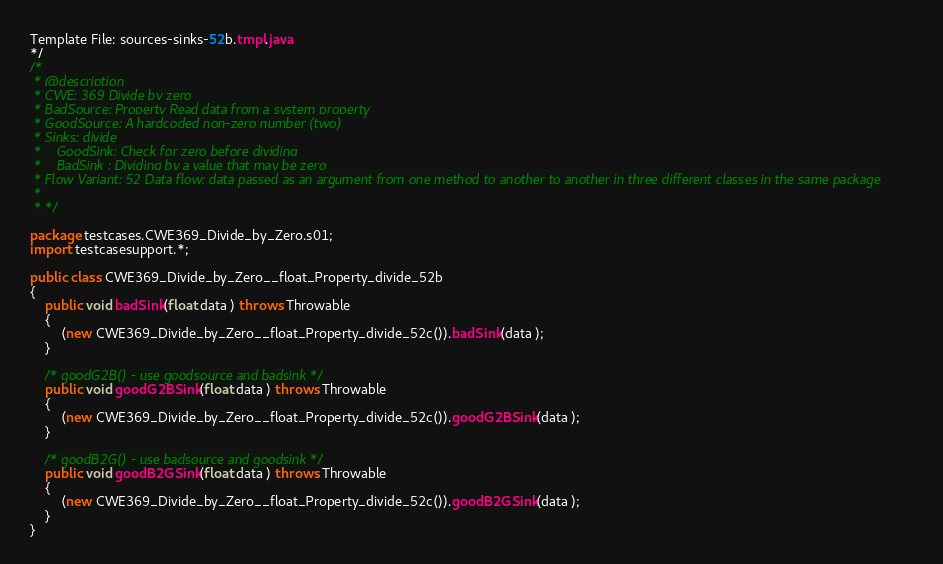Convert code to text. <code><loc_0><loc_0><loc_500><loc_500><_Java_>Template File: sources-sinks-52b.tmpl.java
*/
/*
 * @description
 * CWE: 369 Divide by zero
 * BadSource: Property Read data from a system property
 * GoodSource: A hardcoded non-zero number (two)
 * Sinks: divide
 *    GoodSink: Check for zero before dividing
 *    BadSink : Dividing by a value that may be zero
 * Flow Variant: 52 Data flow: data passed as an argument from one method to another to another in three different classes in the same package
 *
 * */

package testcases.CWE369_Divide_by_Zero.s01;
import testcasesupport.*;

public class CWE369_Divide_by_Zero__float_Property_divide_52b
{
    public void badSink(float data ) throws Throwable
    {
        (new CWE369_Divide_by_Zero__float_Property_divide_52c()).badSink(data );
    }

    /* goodG2B() - use goodsource and badsink */
    public void goodG2BSink(float data ) throws Throwable
    {
        (new CWE369_Divide_by_Zero__float_Property_divide_52c()).goodG2BSink(data );
    }

    /* goodB2G() - use badsource and goodsink */
    public void goodB2GSink(float data ) throws Throwable
    {
        (new CWE369_Divide_by_Zero__float_Property_divide_52c()).goodB2GSink(data );
    }
}
</code> 